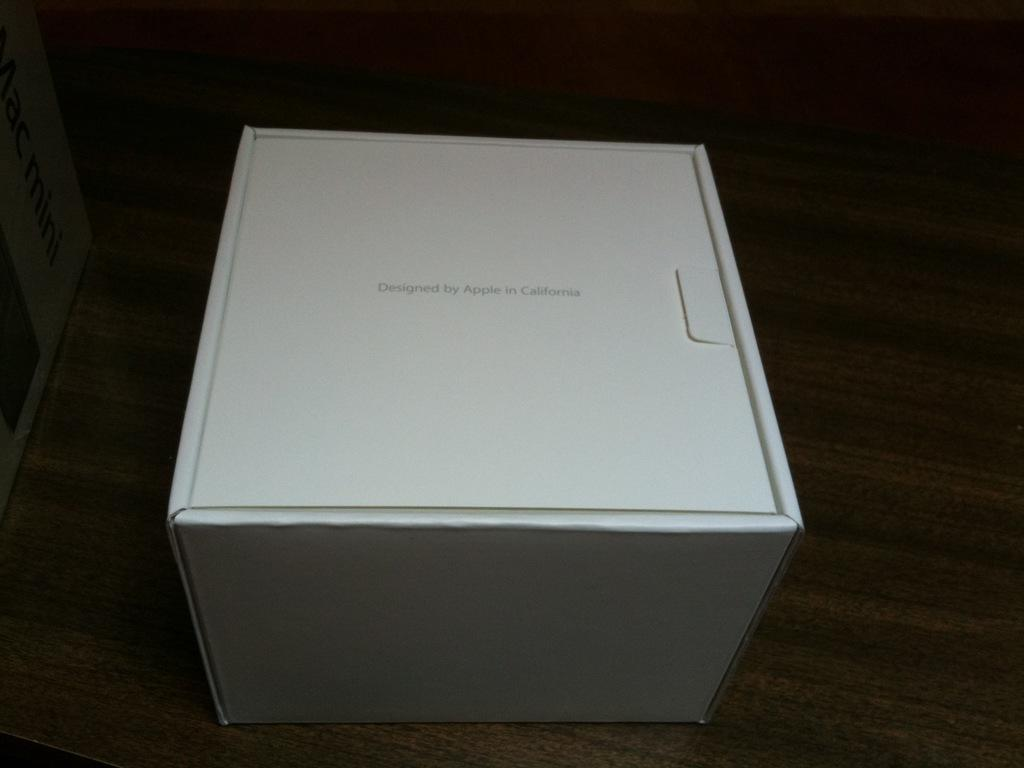What is the color of the box in the image? The box in the image is white in color. What is written or printed on the box? The box has text on it. Where is the box located in the image? The box is placed on a surface. What can be observed about the background of the image? The background of the image is dark in color. Are there any worms crawling on the box in the image? No, there are no worms present in the image. 